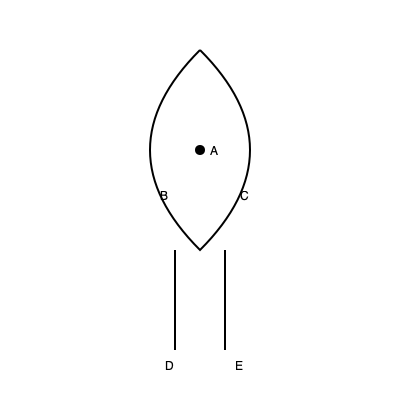In the diagram of the urinary system, what does the structure labeled 'A' represent? To identify the structure labeled 'A' in the diagram, let's break down the anatomy of the urinary system:

1. The diagram shows a simplified representation of the urinary system.
2. The upper, bean-shaped structure represents the kidney.
3. The two tubes extending downward from the kidney are the ureters.
4. The large, central structure is the urinary bladder.
5. The single tube leading from the bottom of the bladder is the urethra.

Structure 'A' is located at the center of the kidney. In the kidney, this central region is known as the renal pelvis. The renal pelvis is a funnel-shaped structure that collects urine from the kidney's collecting ducts before it flows into the ureter.

Given its location and the anatomy of the urinary system, we can conclude that structure 'A' represents the renal pelvis.
Answer: Renal pelvis 